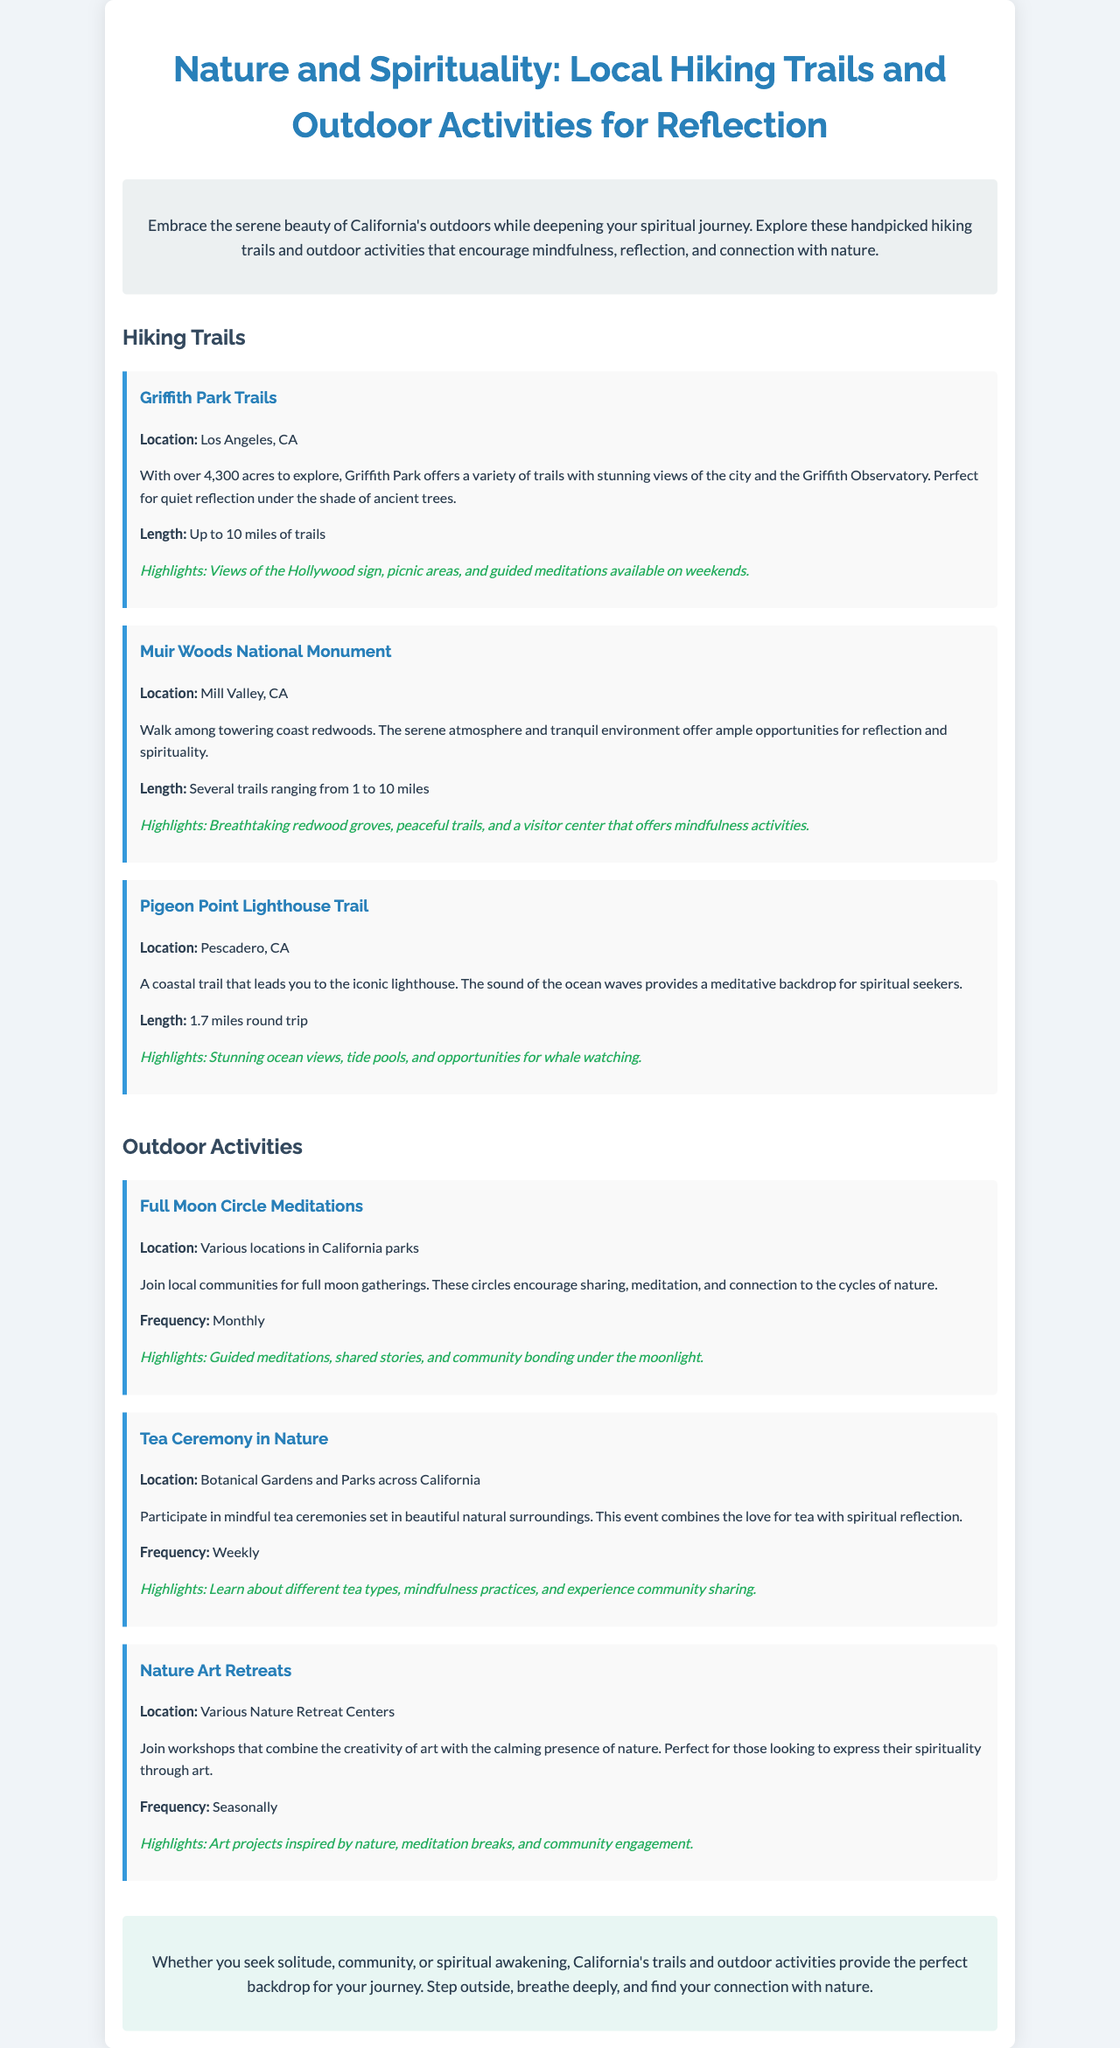What is the location of Griffith Park Trails? The location of Griffith Park Trails is Los Angeles, CA.
Answer: Los Angeles, CA How many miles of trails are available at Griffith Park? The document states that there are up to 10 miles of trails at Griffith Park.
Answer: Up to 10 miles What natural feature is highlighted in Muir Woods National Monument? The highlights for Muir Woods include breathtaking redwood groves.
Answer: Redwood groves How often are the Full Moon Circle Meditations held? The document indicates that Full Moon Circle Meditations are held monthly.
Answer: Monthly What type of event combines tea with spiritual reflection? The event focused on tea and spirituality is the Tea Ceremony in Nature.
Answer: Tea Ceremony in Nature What is the frequency of Nature Art Retreats? Nature Art Retreats occur seasonally according to the document.
Answer: Seasonally What are the challenges presented in the outdoor activities section? The activities encourage sharing, meditation, and connection to the cycles of nature.
Answer: Sharing, meditation, connection 